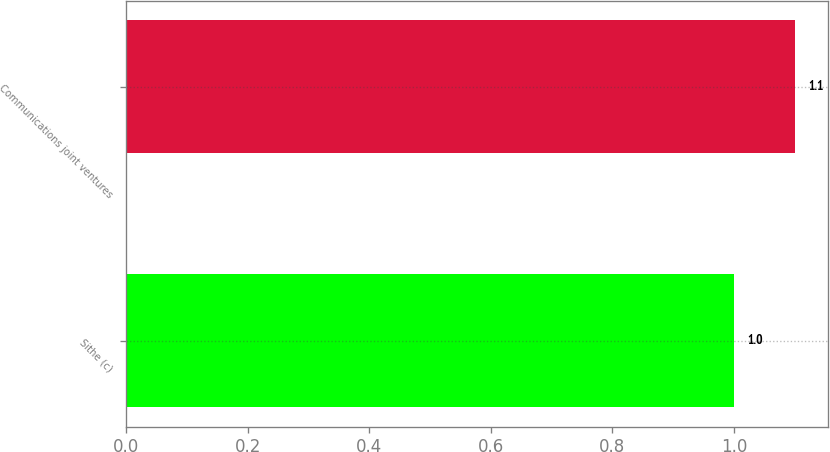<chart> <loc_0><loc_0><loc_500><loc_500><bar_chart><fcel>Sithe (c)<fcel>Communications joint ventures<nl><fcel>1<fcel>1.1<nl></chart> 